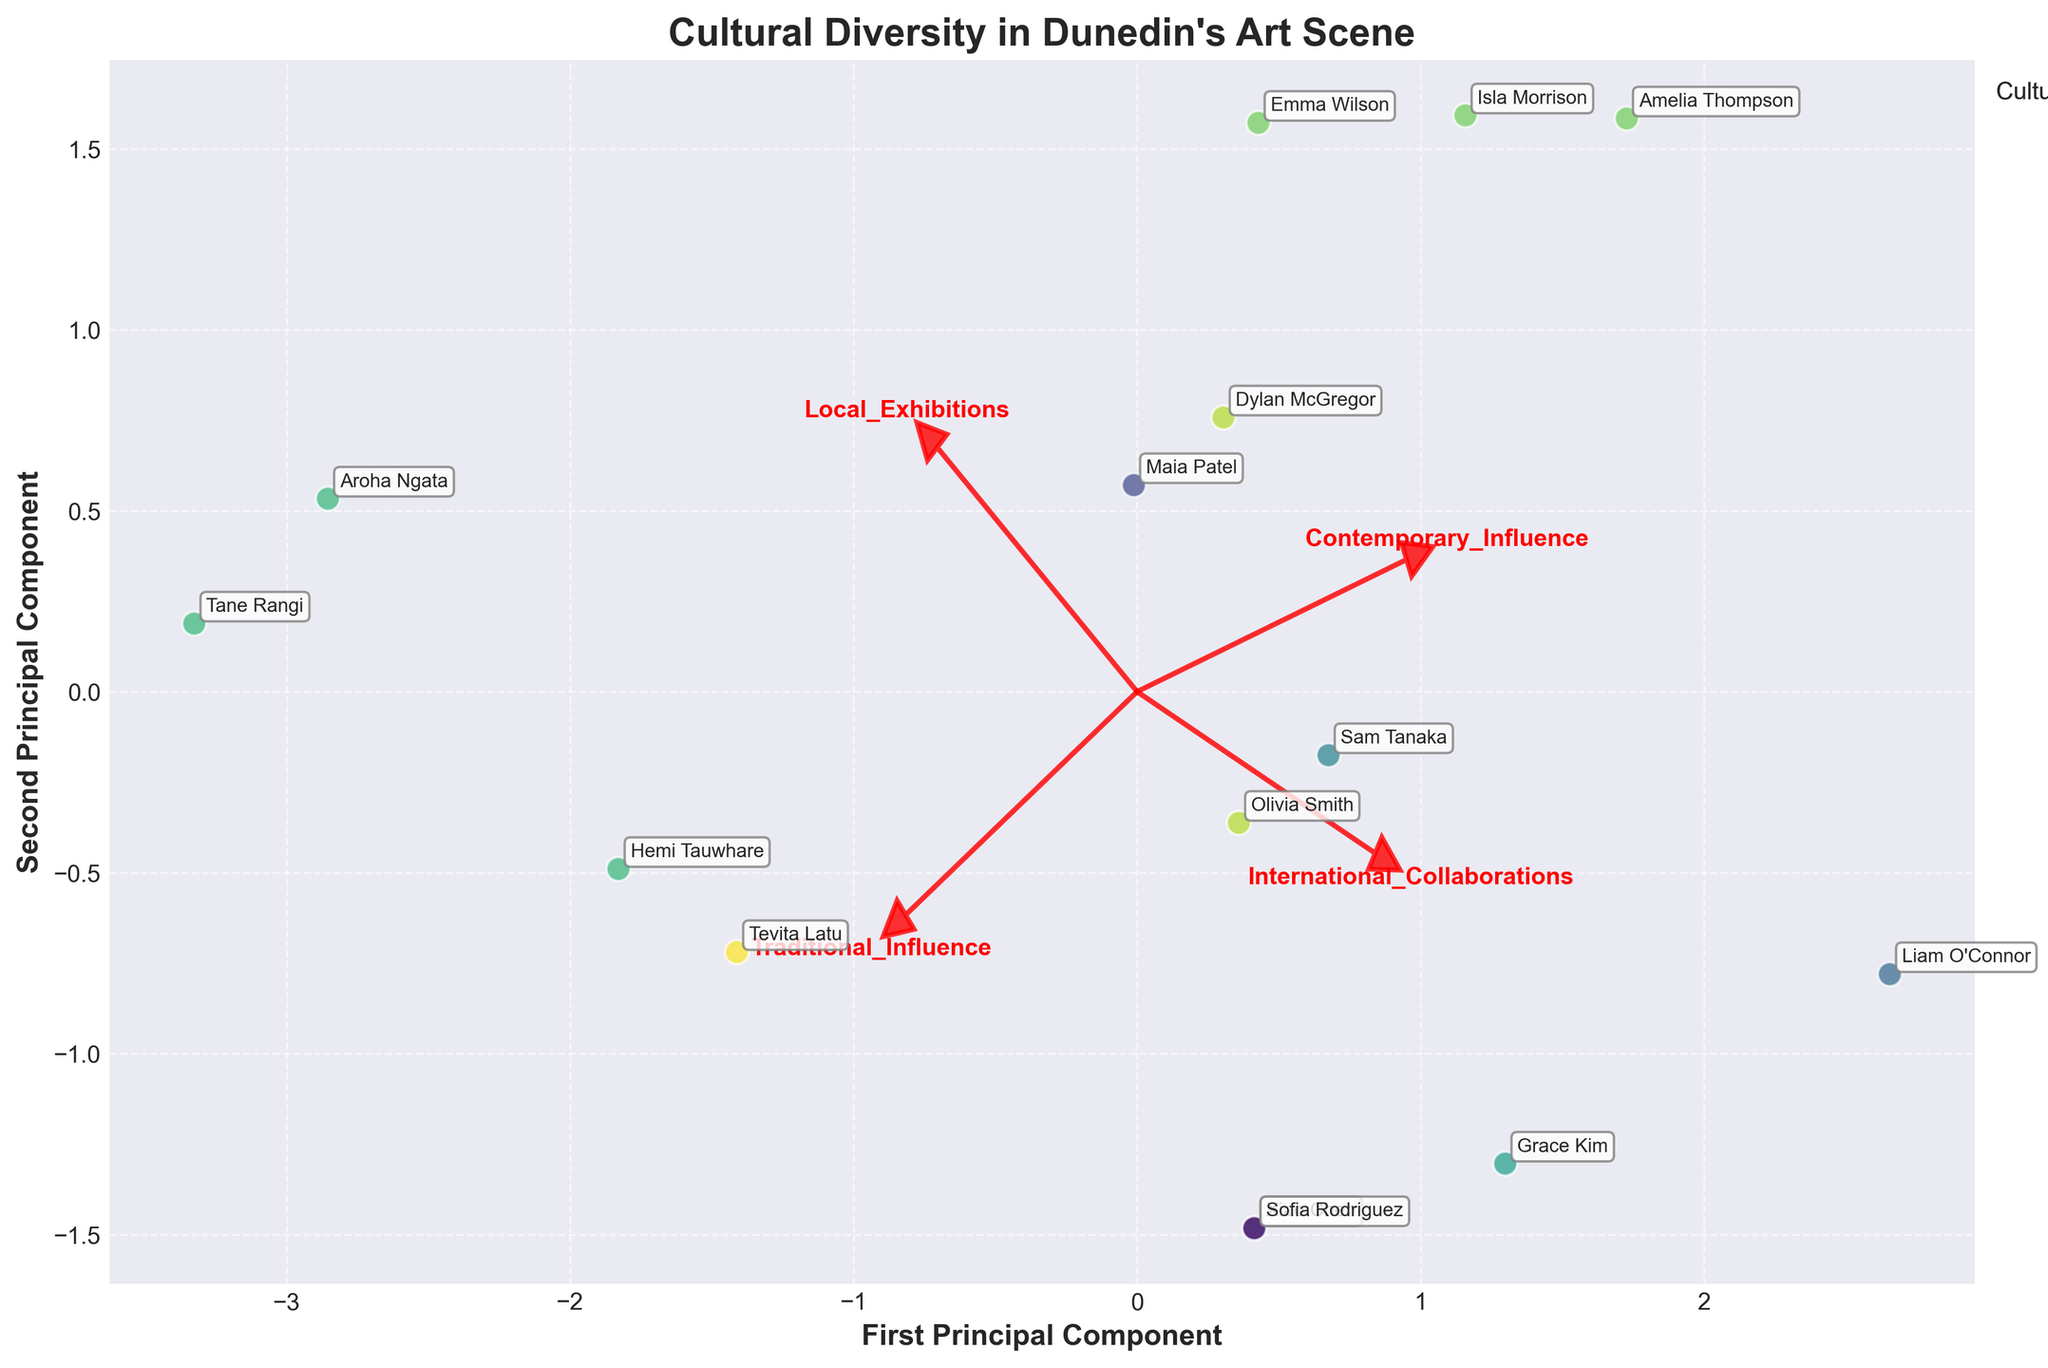What is the title of the biplot? The title is located at the top center of the plot and provides the main subject.
Answer: Cultural Diversity in Dunedin's Art Scene How many artists are represented in the plot? Each point in the scatter plot represents one artist, and you can count the total number of points to get this number.
Answer: 15 Which artist has the highest score in Traditional Influence from a Maori cultural background? The arrow for Traditional Influence and the color representing Maori background help identify this artist. Tane Rangi is highest with Traditional Influence score of 9.
Answer: Tane Rangi Which cultural background has more artists with high Contemporary Influence? Compare the number of points from each cultural background closer to the Contemporary Influence arrow. Pakeha and Scottish artists show higher contemporary influence.
Answer: Pakeha, Scottish What are the coordinates of the first principal component for Hemi Tauwhare? Locate Hemi Tauwhare on the plot and note the x-axis value, which represents the first principal component score.
Answer: (TBA from plot) Which feature has the largest influence on the first principal component? Check the length of the eigenvectors along the direction of the first principal component axis.
Answer: Contemporary Influence Does the plot show any artists with high local exhibitions but low traditional influence? Look for points that align closely with the Local Exhibitions arrow but away from the Traditional Influence arrow.
Answer: Yes How many arrows (features) are displayed in the biplot? Count the number of red arrows depicted, each representing a different feature.
Answer: 4 Which artist is annotated closest to the origin (0,0)? Identify the artist label that is nearest to the origin of the plot.
Answer: TBA from plot Do Maori artists tend to have high or low international collaborations? Review the positions of the Maori artists relative to the International Collaborations arrow. Some variation, but generally moderate values.
Answer: Moderate 